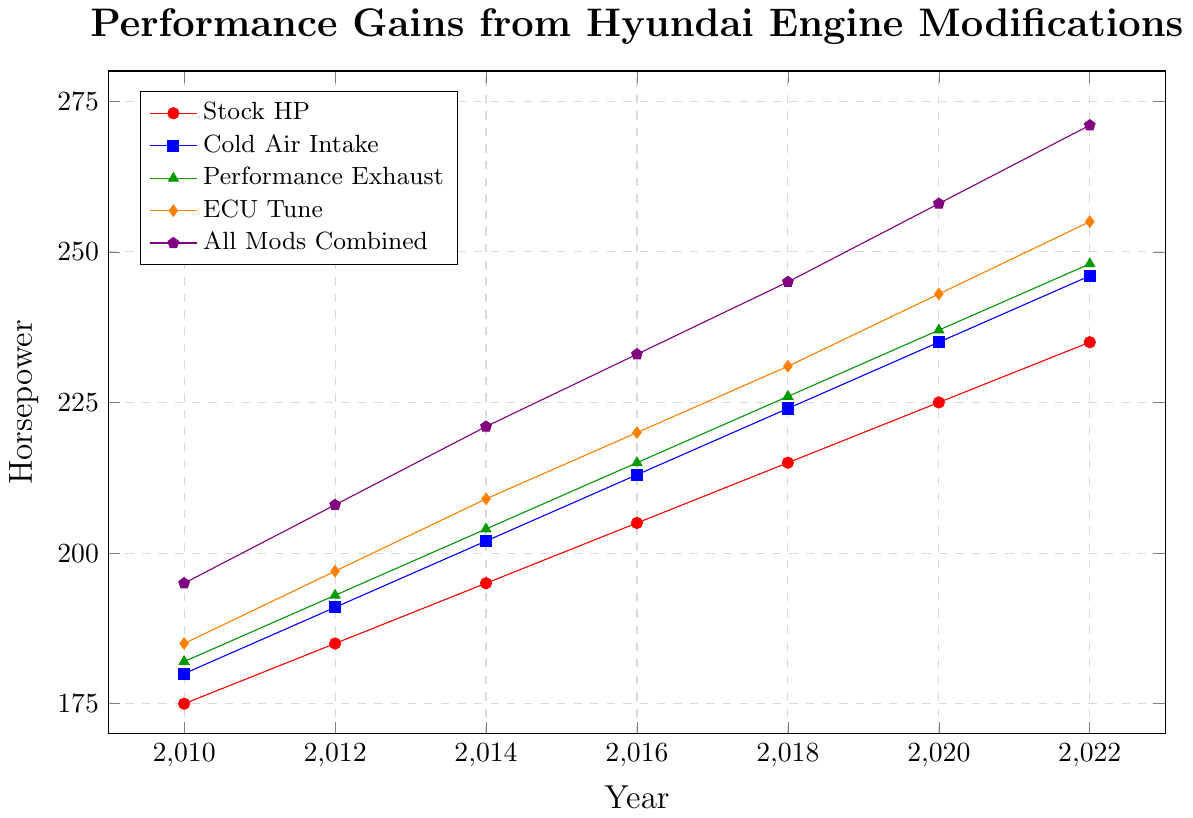What was the horsepower gain from the stock configuration to the "All Mods Combined" in the year 2014? First, find the stock HP for 2014, which is 195 HP. Then, find the "All Mods Combined" HP for 2014, which is 221 HP. The gain is 221 HP - 195 HP.
Answer: 26 HP Which modification shows the largest increase in horsepower from 2010 to 2022? Check the HP values for each modification in 2010 and 2022. "Cold Air Intake" goes from 180 HP to 246 HP, "Performance Exhaust" goes from 182 HP to 248 HP, "ECU Tune" goes from 185 HP to 255 HP, and "All Mods Combined" goes from 195 HP to 271 HP. The "All Mods Combined" has the highest increase of 76 HP.
Answer: All Mods Combined How does the horsepower gain in 2020 from a performance exhaust compare to that from a cold air intake? In 2020, the HP with "Performance Exhaust" is 237, and with "Cold Air Intake" it is 235. Find the difference by subtracting 235 from 237.
Answer: 2 HP higher What is the combined average horsepower for all modifications (excluding the stock) in 2016? Find the HP values in 2016: Cold Air Intake (213), Performance Exhaust (215), ECU Tune (220), All Mods Combined (233). Add them up: 213 + 215 + 220 + 233 = 881. Divide by the number of modifications (4).
Answer: 220.25 HP Between which years did the ECU Tune experience its highest increase in horsepower? Calculating the differences between consecutive years for ECU Tune: 2010-2012 (12 HP), 2012-2014 (12 HP), 2014-2016 (11 HP), 2016-2018 (11 HP), 2018-2020 (12 HP), 2020-2022 (12 HP). The highest increase is between 2010 and 2012, 2012 and 2014, 2018 and 2020, and 2020 and 2022, all with 12 HP each.
Answer: 2010-2012, 2012-2014, 2018-2020, 2020-2022 In which year did all modifications exceed 200 horsepower for the first time? Looking at each modification: Cold Air Intake exceeds 200 HP in 2014, Performance Exhaust in 2014, ECU Tune in 2014, All Mods Combined in 2014. Thus, they all exceed 200 HP in 2014 for the first time.
Answer: 2014 What is the difference in horsepower between the "Cold Air Intake" modification in 2014 and the "ECU Tune" in 2016? The Cold Air Intake HP in 2014 is 202, and the ECU Tune HP in 2016 is 220. Find the difference: 220 - 202.
Answer: 18 HP If someone wants the maximum possible increase in horsepower in 2022, which modification should they choose and how much will the increase be from the stock HP? In 2022, find the stock HP (235) and the "All Mods Combined" HP (271). The increase is 271 - 235.
Answer: All Mods Combined, 36 HP 